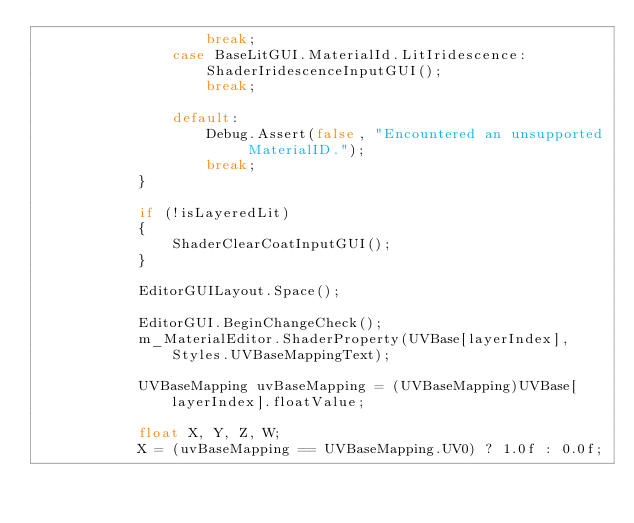Convert code to text. <code><loc_0><loc_0><loc_500><loc_500><_C#_>                    break;
                case BaseLitGUI.MaterialId.LitIridescence:
                    ShaderIridescenceInputGUI();
                    break;

                default:
                    Debug.Assert(false, "Encountered an unsupported MaterialID.");
                    break;
            }

            if (!isLayeredLit)
            {
                ShaderClearCoatInputGUI();
            }

            EditorGUILayout.Space();

            EditorGUI.BeginChangeCheck();
            m_MaterialEditor.ShaderProperty(UVBase[layerIndex], Styles.UVBaseMappingText);

            UVBaseMapping uvBaseMapping = (UVBaseMapping)UVBase[layerIndex].floatValue;

            float X, Y, Z, W;
            X = (uvBaseMapping == UVBaseMapping.UV0) ? 1.0f : 0.0f;</code> 